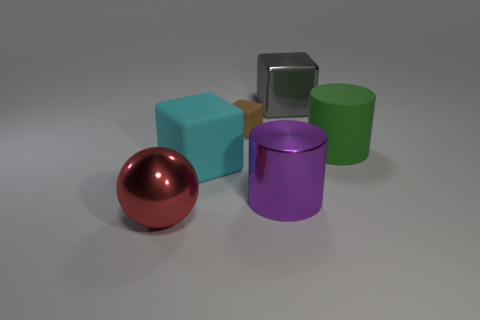Subtract all cyan blocks. How many blocks are left? 2 Subtract all big gray blocks. How many blocks are left? 2 Subtract all balls. How many objects are left? 5 Subtract all blue cylinders. How many gray blocks are left? 1 Add 3 red things. How many objects exist? 9 Subtract all yellow cylinders. Subtract all brown cubes. How many cylinders are left? 2 Subtract all purple metal cylinders. Subtract all large cylinders. How many objects are left? 3 Add 4 purple metallic cylinders. How many purple metallic cylinders are left? 5 Add 1 tiny red shiny cylinders. How many tiny red shiny cylinders exist? 1 Subtract 0 gray balls. How many objects are left? 6 